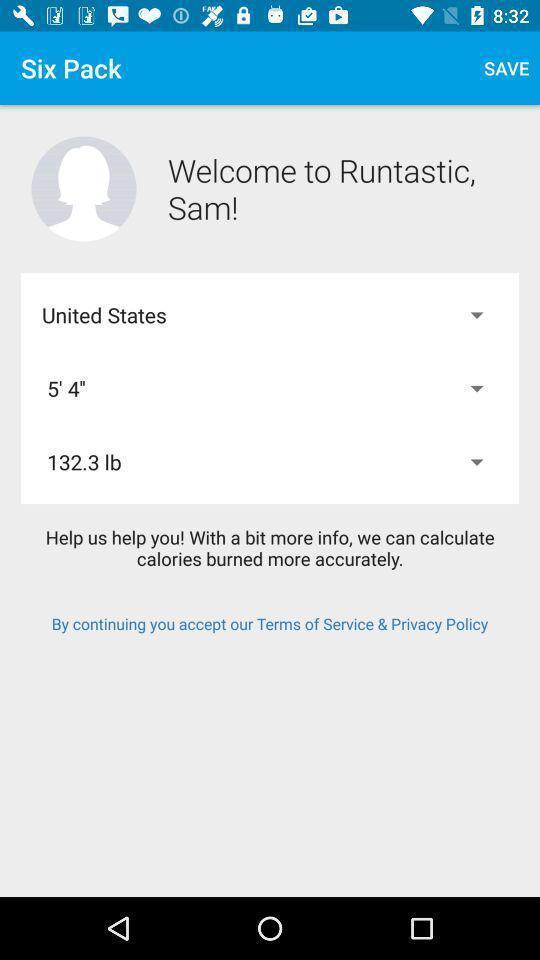Describe the visual elements of this screenshot. Welcome page with details in a calorie tracking app. 